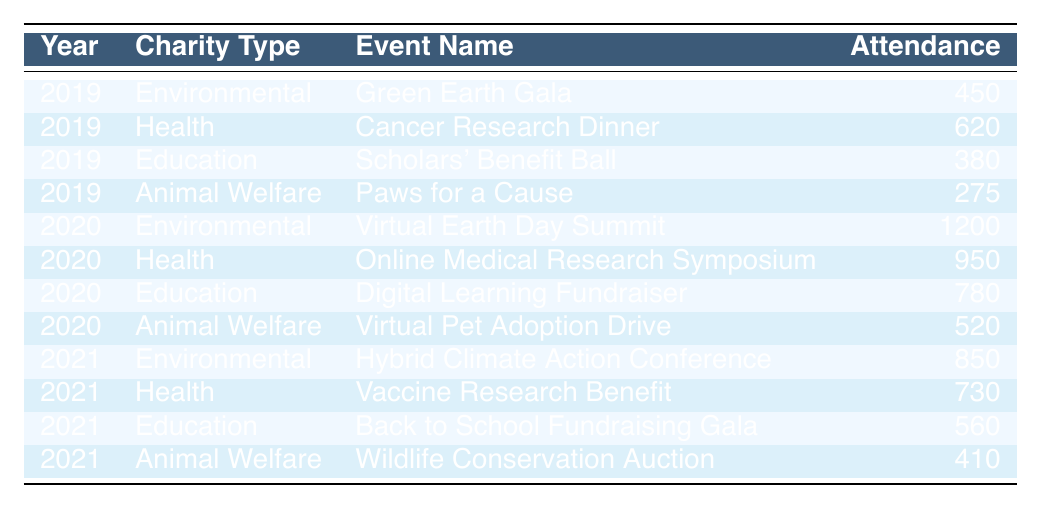What was the attendance at the Green Earth Gala in 2019? The table indicates that the attendance at the Green Earth Gala, listed under the Environmental charity type for the year 2019, was 450.
Answer: 450 Which charity type had the highest attendance in 2020? In 2020, the table shows that the Environmental charity type had the highest attendance at the Virtual Earth Day Summit with 1200 attendees compared to other charity types.
Answer: Environmental What was the attendance difference between the Cancer Research Dinner in 2019 and the Online Medical Research Symposium in 2020? The attendance for the Cancer Research Dinner in 2019 was 620, and for the Online Medical Research Symposium in 2020 it was 950. The difference is 950 - 620 = 330.
Answer: 330 What was the average attendance for the Animal Welfare charity events across the three years? The attendances for Animal Welfare events are 275 in 2019, 520 in 2020, and 410 in 2021. The average is (275 + 520 + 410) / 3 = 401.67, rounded to 402.
Answer: 402 Did the attendance for Education events increase from 2019 to 2021? In 2019, the attendance was 380 for the Scholars' Benefit Ball, and in 2021 it was 560 for the Back to School Fundraising Gala. Since 560 > 380, the attendance did increase.
Answer: Yes Which year saw the lowest overall attendance in total from all charity types combined? Adding up the attendances: 2019 (450 + 620 + 380 + 275 = 1725), 2020 (1200 + 950 + 780 + 520 = 3450), and 2021 (850 + 730 + 560 + 410 = 2550). The lowest total was 1725 in 2019.
Answer: 2019 What was the total attendance for Health charity events over the three years? The total attendances for Health charity events are 620 in 2019, 950 in 2020, and 730 in 2021. Adding them gives 620 + 950 + 730 = 2300.
Answer: 2300 In which year did the Education charity type have the lowest attendance? The Education charity events had attendances of 380 in 2019, 780 in 2020, and 560 in 2021. The lowest attendance was 380 in 2019.
Answer: 2019 Which charity type saw the highest growth in attendance from 2019 to 2020? Environmental saw an increase from 450 in 2019 to 1200 in 2020, a growth of 750. Health increased from 620 in 2019 to 950 in 2020, a growth of 330. Education increased from 380 in 2019 to 780 in 2020, a growth of 400. Thus, Environmental had the highest growth of 750.
Answer: Environmental 